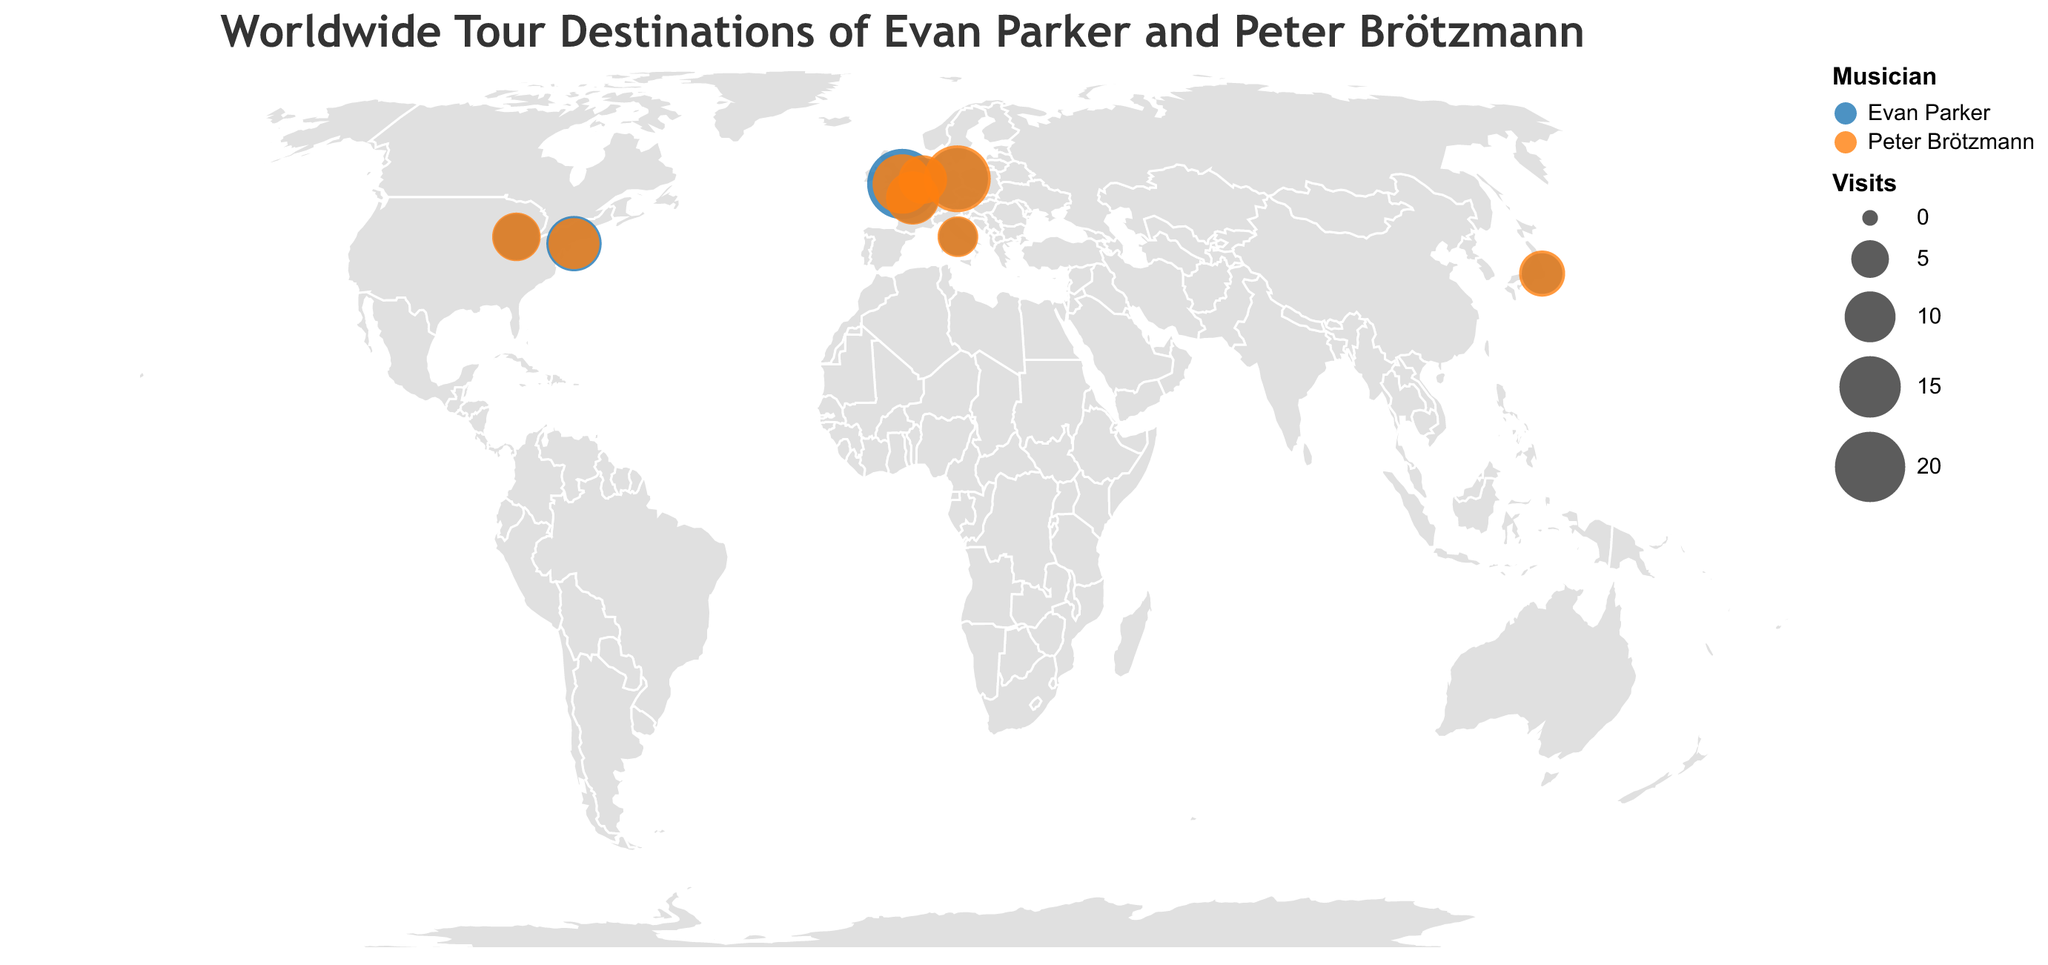How many cities in the United States did Evan Parker visit? By looking at the plot and counting the cities marked in the United States that correspond to Evan Parker, which are labeled directly on the map.
Answer: 2 Which musician has visited Berlin more frequently, and how many times more? Compare the sizes of the circles in Berlin for both Evan Parker and Peter Brötzmann. Evan Parker has visited Berlin 15 times, whereas Peter Brötzmann has visited 18 times. Calculate the difference: 18 - 15 = 3.
Answer: Peter Brötzmann, 3 times more What is the total number of visits Evan Parker made to European cities? Look at the plot and sum the visits to European cities for Evan Parker: Berlin (15), London (20), Paris (10), Amsterdam (7), Rome (5). The total is 15 + 20 + 10 + 7 + 5 = 57.
Answer: 57 Which city appears to be the most popular destination for both musicians combined? Add up the visits for both musicians for each city on the plot and identify the city with the highest total: New York (12+10=22), Chicago (8+9=17), Berlin (15+18=33), London (20+14=34), Tokyo (6+8=14), Paris (10+11=21), Amsterdam (7+9=16), Rome (5+6=11). London has the highest total with 34.
Answer: London What is the ratio of Peter Brötzmann's visits to Evan Parker's visits in Amsterdam? Compare the frequencies of visits to Amsterdam for both musicians. Peter Brötzmann has 9 visits and Evan Parker has 7 visits. The ratio is 9:7 or 9/7.
Answer: 9:7 What is the average number of visits Evan Parker made to the cities listed? Sum the visits made by Evan Parker and divide by the number of cities he has visited: (12 + 8 + 15 + 20 + 6 + 10 + 7 + 5) / 8. Total is 83 visits, so the average is 83 / 8 ≈ 10.375.
Answer: 10.375 Which musician has a more evenly distributed number of visits across all cities? Compare the variation in visit numbers for both musicians. Evan Parker: {12, 8, 15, 20, 6, 10, 7, 5}. Peter Brötzmann: {10, 9, 18, 14, 8, 11, 9, 6}. Evan Parker's visits range from 5 to 20, while Peter Brötzmann's range from 6 to 18. Peter Brötzmann has a more evenly distributed number of visits.
Answer: Peter Brötzmann How many more times did Evan Parker visit London compared to his visits to Rome? Compare the visits to London and Rome for Evan Parker: 20 for London and 5 for Rome. The difference is 20 - 5 = 15.
Answer: 15 